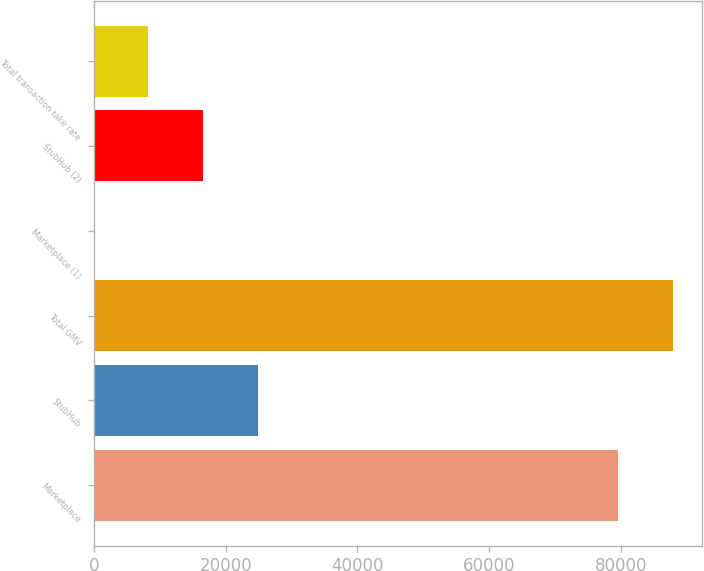Convert chart. <chart><loc_0><loc_0><loc_500><loc_500><bar_chart><fcel>Marketplace<fcel>StubHub<fcel>Total GMV<fcel>Marketplace (1)<fcel>StubHub (2)<fcel>Total transaction take rate<nl><fcel>79581<fcel>24831.5<fcel>87855.5<fcel>7.98<fcel>16557<fcel>8282.48<nl></chart> 